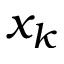<formula> <loc_0><loc_0><loc_500><loc_500>x _ { k }</formula> 